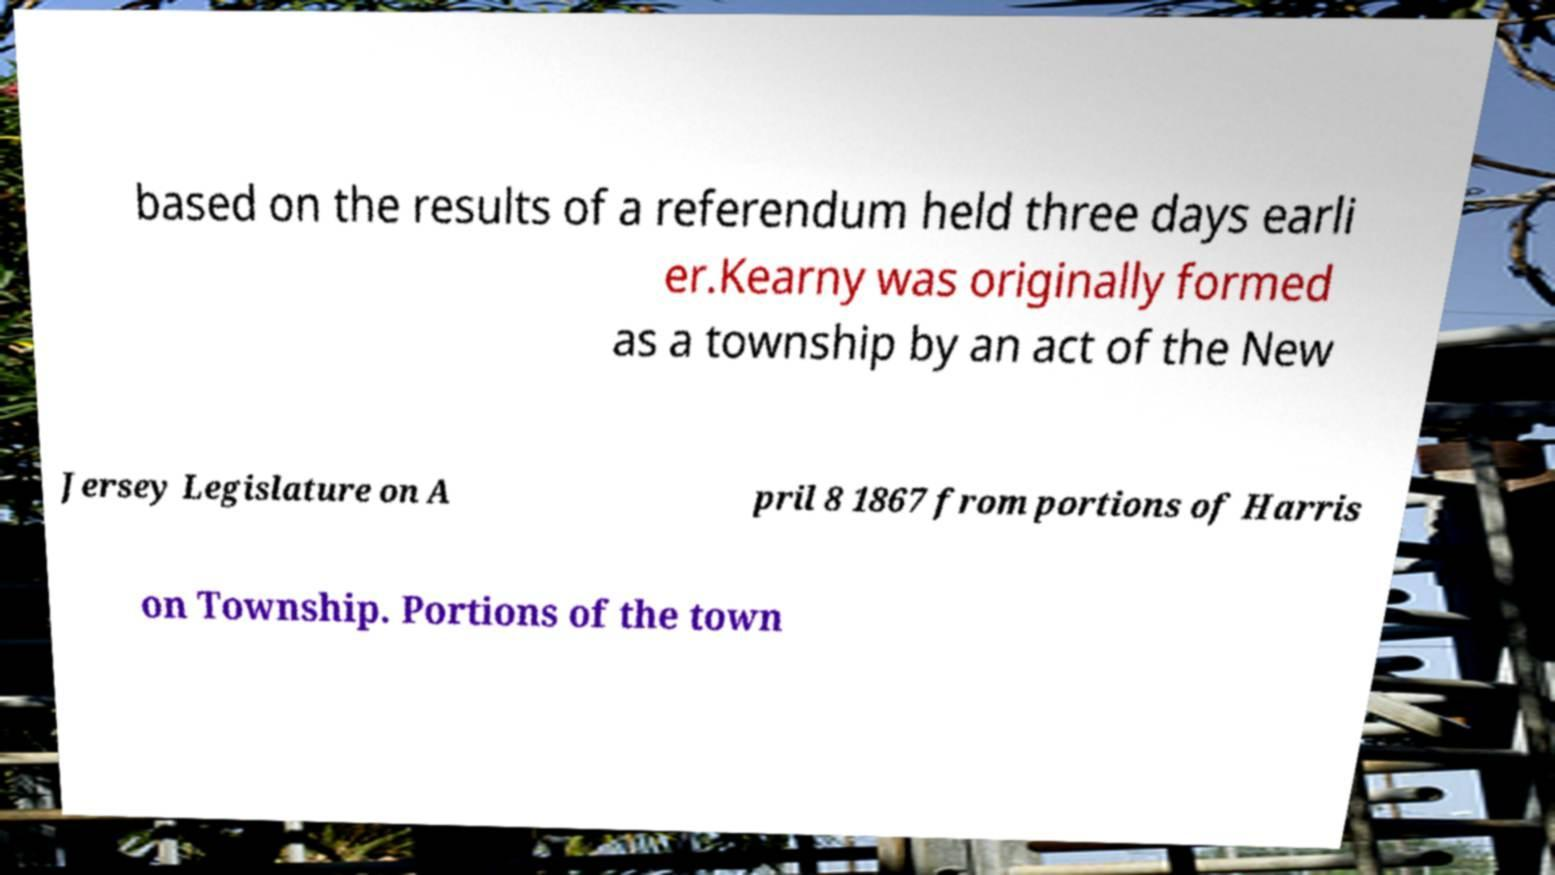Please identify and transcribe the text found in this image. based on the results of a referendum held three days earli er.Kearny was originally formed as a township by an act of the New Jersey Legislature on A pril 8 1867 from portions of Harris on Township. Portions of the town 